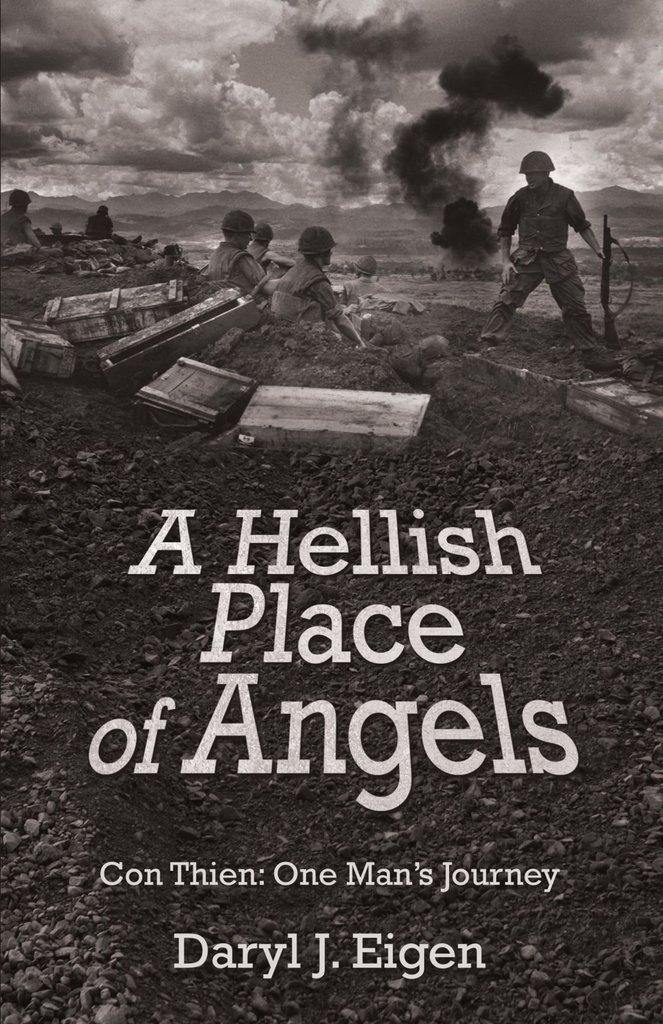Who wrote this book?
Your answer should be very brief. Daryl j. eigen. What is the title of the book?
Offer a terse response. A hellish place of angels. 